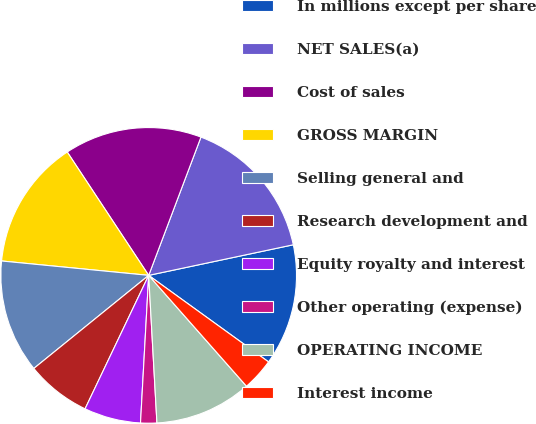<chart> <loc_0><loc_0><loc_500><loc_500><pie_chart><fcel>In millions except per share<fcel>NET SALES(a)<fcel>Cost of sales<fcel>GROSS MARGIN<fcel>Selling general and<fcel>Research development and<fcel>Equity royalty and interest<fcel>Other operating (expense)<fcel>OPERATING INCOME<fcel>Interest income<nl><fcel>13.27%<fcel>15.93%<fcel>15.04%<fcel>14.16%<fcel>12.39%<fcel>7.08%<fcel>6.2%<fcel>1.77%<fcel>10.62%<fcel>3.54%<nl></chart> 